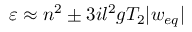<formula> <loc_0><loc_0><loc_500><loc_500>\varepsilon \approx n ^ { 2 } \pm 3 i l ^ { 2 } g T _ { 2 } | w _ { e q } |</formula> 